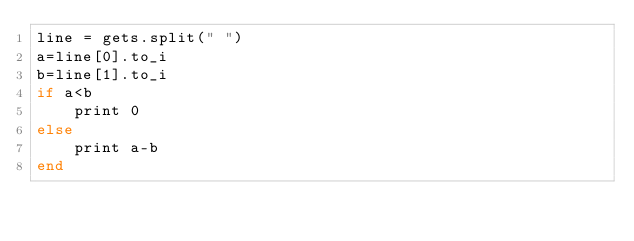Convert code to text. <code><loc_0><loc_0><loc_500><loc_500><_Ruby_>line = gets.split(" ")
a=line[0].to_i
b=line[1].to_i
if a<b
    print 0
else
    print a-b
end</code> 